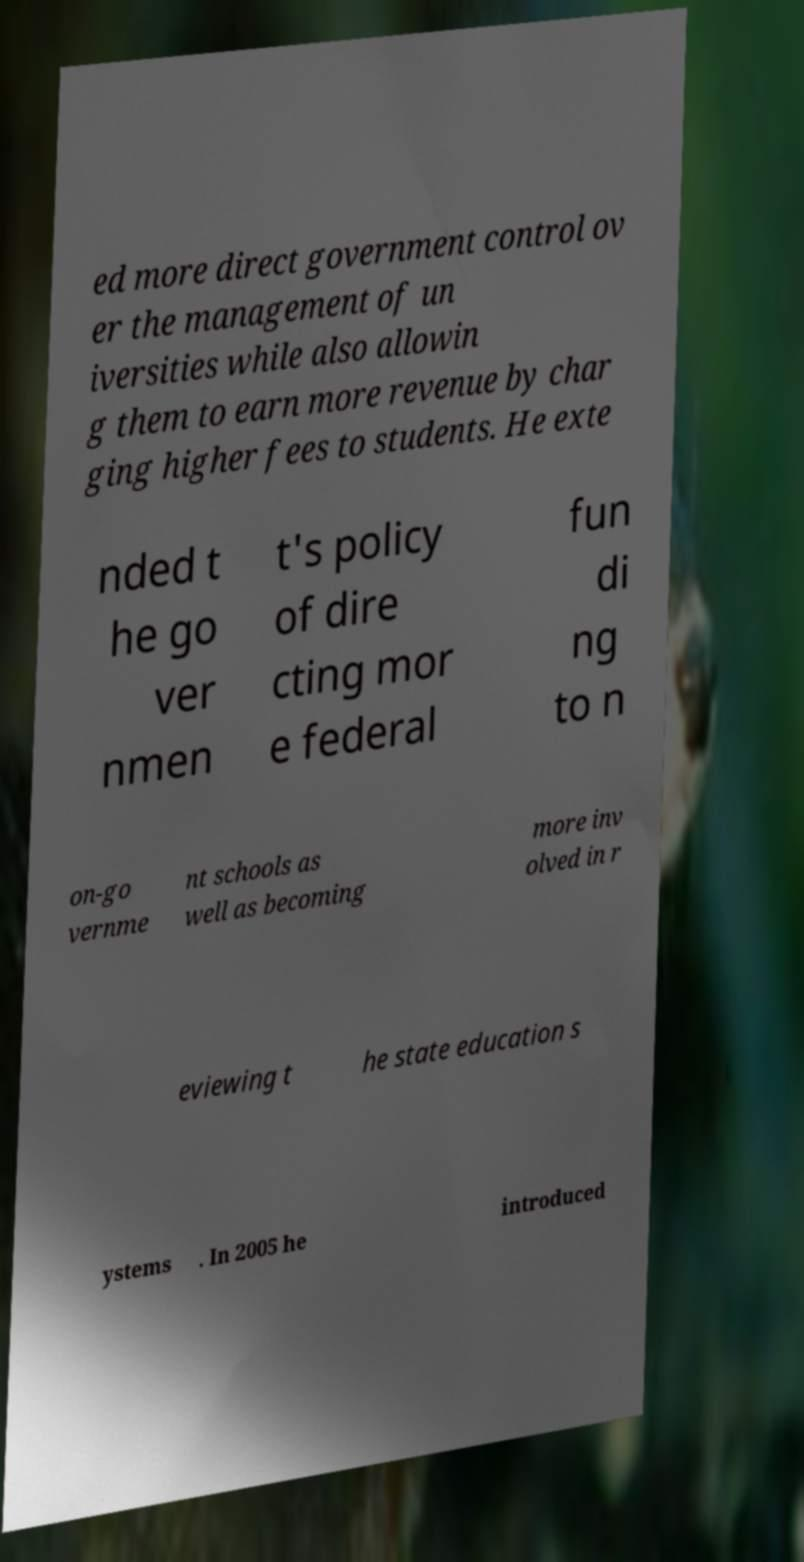Could you extract and type out the text from this image? ed more direct government control ov er the management of un iversities while also allowin g them to earn more revenue by char ging higher fees to students. He exte nded t he go ver nmen t's policy of dire cting mor e federal fun di ng to n on-go vernme nt schools as well as becoming more inv olved in r eviewing t he state education s ystems . In 2005 he introduced 